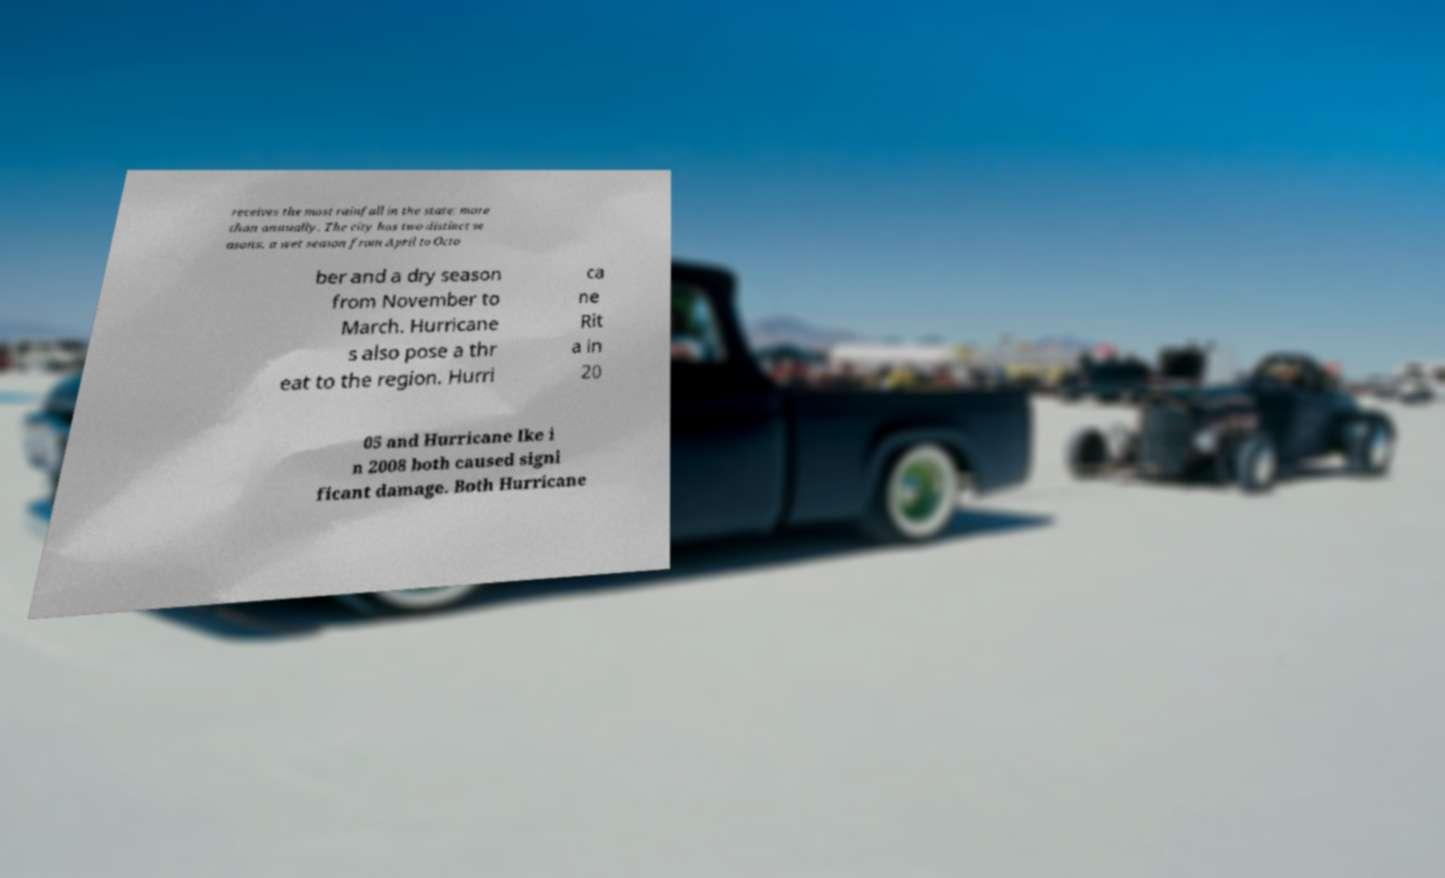I need the written content from this picture converted into text. Can you do that? receives the most rainfall in the state: more than annually. The city has two distinct se asons, a wet season from April to Octo ber and a dry season from November to March. Hurricane s also pose a thr eat to the region. Hurri ca ne Rit a in 20 05 and Hurricane Ike i n 2008 both caused signi ficant damage. Both Hurricane 